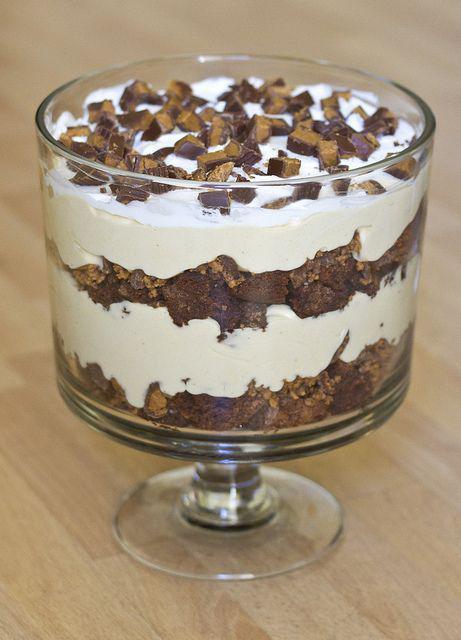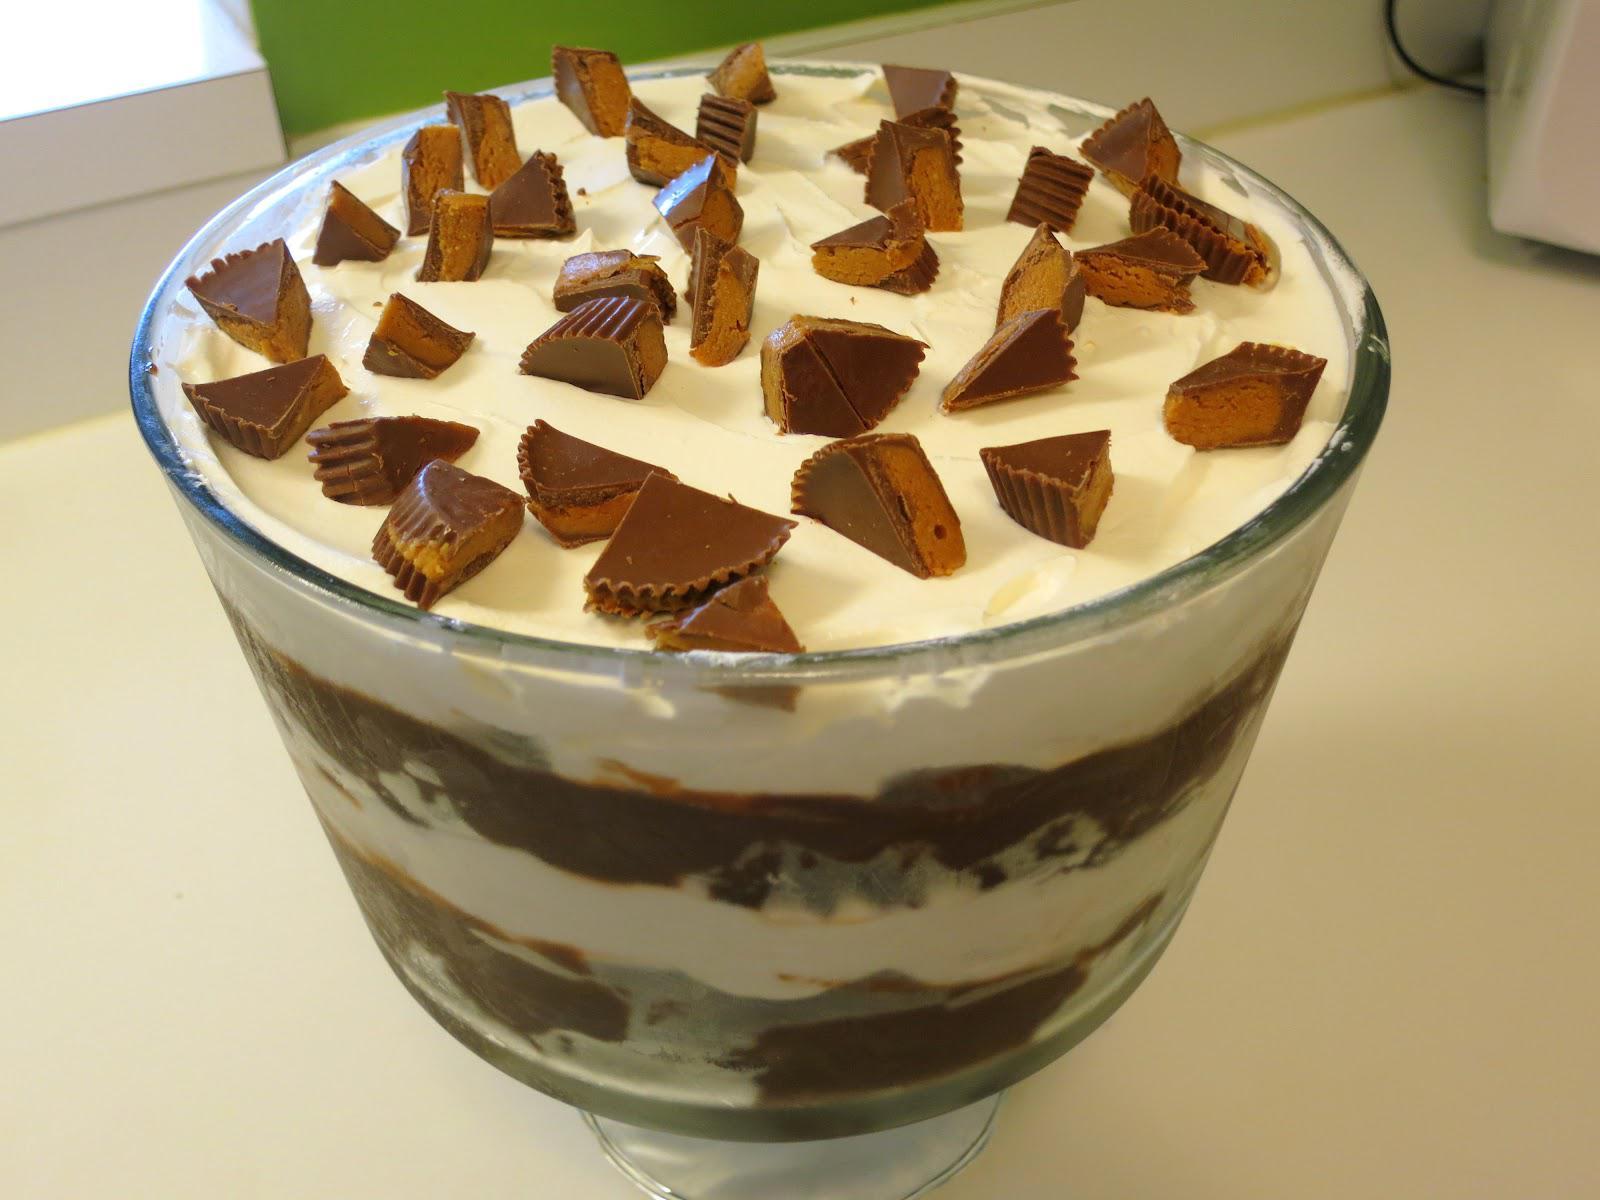The first image is the image on the left, the second image is the image on the right. For the images shown, is this caption "There is one layered dessert in each image, and they are both in dishes with stems." true? Answer yes or no. Yes. 